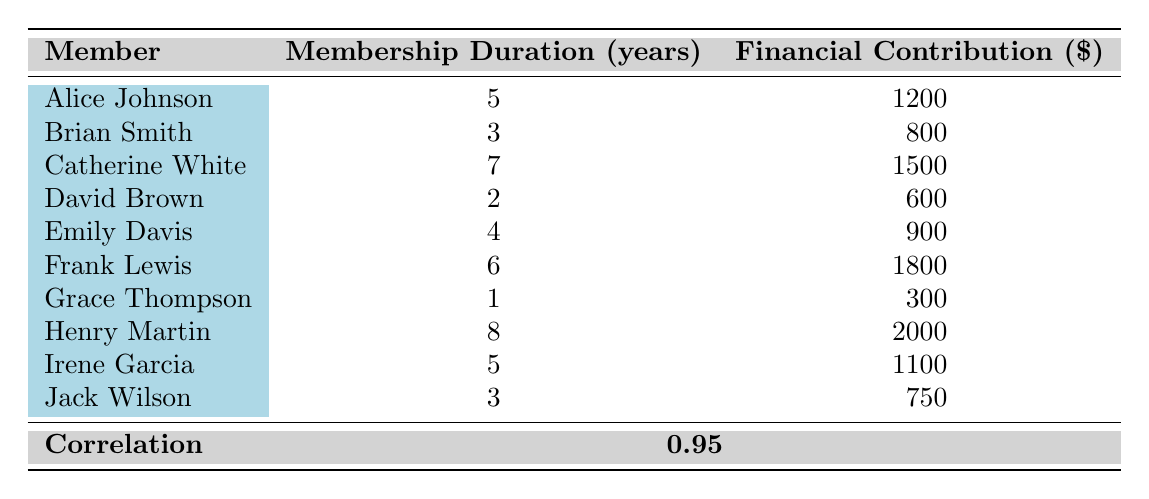What is the financial contribution of Henry Martin? From the table under the "Financial Contribution ($)" column, we can see that Henry Martin's financial contribution is listed as 2000.
Answer: 2000 What is the membership duration of Grace Thompson? The table shows that Grace Thompson has a membership duration of 1 year listed under the "Membership Duration (years)" column.
Answer: 1 Who has the highest financial contribution? By looking at the "Financial Contribution ($)" column, we see that Henry Martin has the highest contribution at 2000, which is greater than all other members.
Answer: Henry Martin What is the average financial contribution of members with more than 4 years of membership? Members with more than 4 years of membership are Catherine White (1500), Frank Lewis (1800), Henry Martin (2000), and Irene Garcia (1100). The sum is 1500 + 1800 + 2000 + 1100 = 7400. There are 4 members, so the average is 7400 / 4 = 1850.
Answer: 1850 Is it true that all members with at least 6 years of membership have contributed more than 1500? Frank Lewis has 6 years and contributed 1800, and Henry Martin has 8 years and contributed 2000, both of which are greater than 1500. Therefore, it's true that all members with at least 6 years of membership contributed more than 1500.
Answer: Yes How many members have contributed less than 1000? Looking at the table, we have David Brown (600), Brian Smith (800), Jack Wilson (750), and Grace Thompson (300), which gives us a total of 4 members who contributed less than 1000.
Answer: 4 What is the difference in financial contribution between the member with the longest membership and the member with the shortest? Henry Martin has the longest membership of 8 years with a contribution of 2000, while Grace Thompson has the shortest membership of 1 year with a contribution of 300. The difference in contribution is 2000 - 300 = 1700.
Answer: 1700 What is the total financial contribution of all members? Adding all the financial contributions: 1200 + 800 + 1500 + 600 + 900 + 1800 + 300 + 2000 + 1100 + 750 = 10350.
Answer: 10350 Is there a correlation between membership duration and financial contribution? The table shows a correlation value of 0.95, which indicates a strong positive correlation between membership duration and financial contributions.
Answer: Yes 